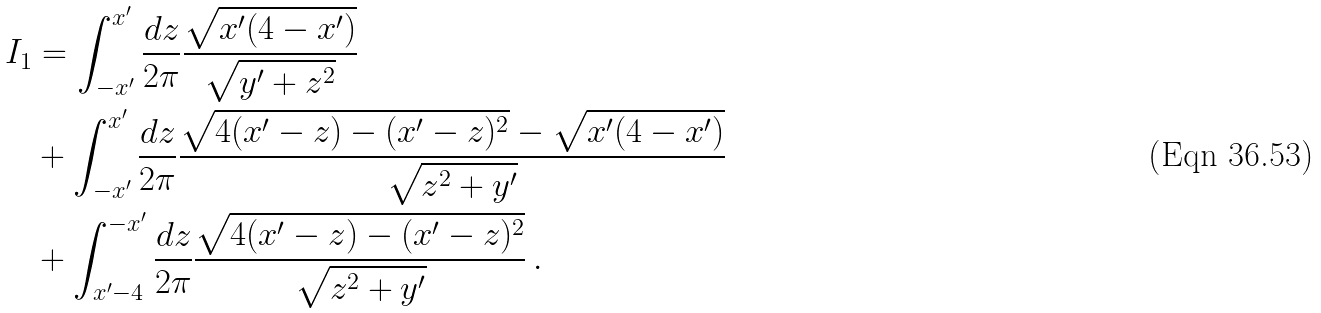Convert formula to latex. <formula><loc_0><loc_0><loc_500><loc_500>I _ { 1 } & = \int _ { - x ^ { \prime } } ^ { x ^ { \prime } } \frac { d z } { 2 \pi } \frac { \sqrt { x ^ { \prime } ( 4 - x ^ { \prime } ) } } { \sqrt { y ^ { \prime } + z ^ { 2 } } } \\ & + \int _ { - x ^ { \prime } } ^ { x ^ { \prime } } \frac { d z } { 2 \pi } \frac { \sqrt { 4 ( x ^ { \prime } - z ) - ( x ^ { \prime } - z ) ^ { 2 } } - \sqrt { x ^ { \prime } ( 4 - x ^ { \prime } ) } } { \sqrt { z ^ { 2 } + y ^ { \prime } } } \, \\ & + \int _ { x ^ { \prime } - 4 } ^ { - x ^ { \prime } } \frac { d z } { 2 \pi } \frac { \sqrt { 4 ( x ^ { \prime } - z ) - ( x ^ { \prime } - z ) ^ { 2 } } } { \sqrt { z ^ { 2 } + y ^ { \prime } } } \, .</formula> 